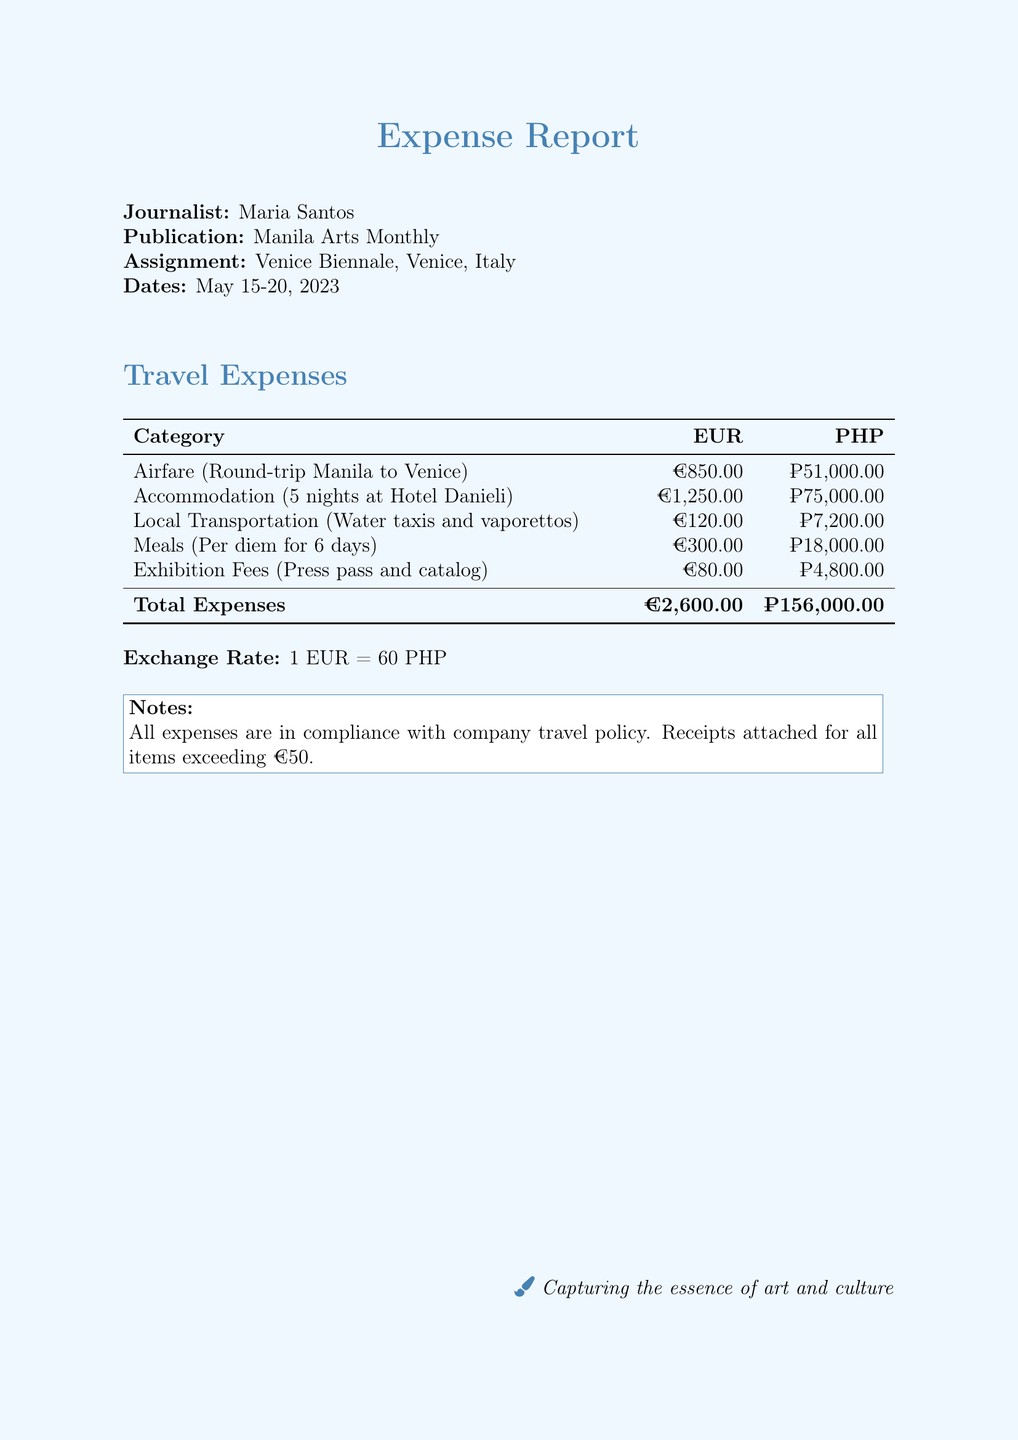What is the name of the journalist? The document states the journalist's name at the beginning.
Answer: Maria Santos What was the assignment location? The assignment location is provided clearly under the title section of the document.
Answer: Venice Biennale, Venice, Italy How many nights was the accommodation for? The document specifies the duration of the accommodation in the travel expenses section.
Answer: 5 nights What is the total expense in PHP? The total expense is calculated and listed in the table of travel expenses.
Answer: ₱156,000.00 What is the cost of the airfare? The airfare cost is listed under the travel expenses category in the document.
Answer: €850.00 What is the exchange rate stated in the document? The exchange rate is explicitly mentioned in the last section of the document.
Answer: 1 EUR = 60 PHP Which category incurred the highest cost? By comparing the figures in the travel expenses table, we identify which is the highest.
Answer: Accommodation What does the notes section indicate about the receipts? The notes section describes the policy regarding receipts for expenses.
Answer: Receipts attached for all items exceeding €50 